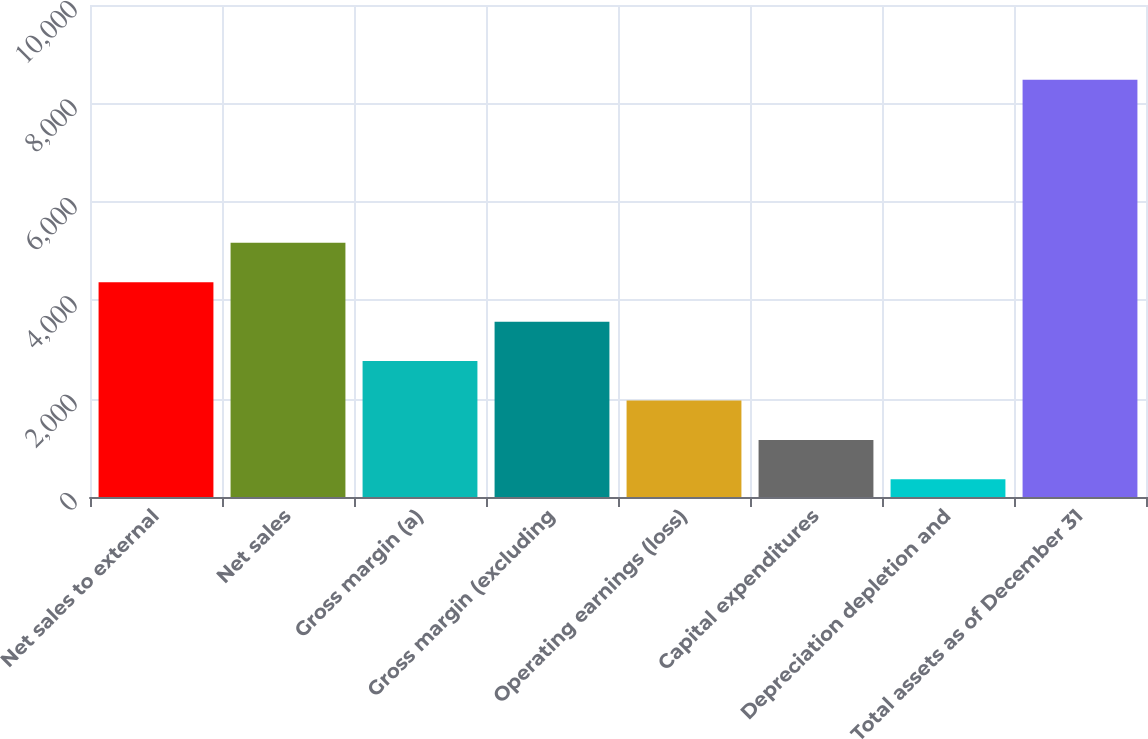<chart> <loc_0><loc_0><loc_500><loc_500><bar_chart><fcel>Net sales to external<fcel>Net sales<fcel>Gross margin (a)<fcel>Gross margin (excluding<fcel>Operating earnings (loss)<fcel>Capital expenditures<fcel>Depreciation depletion and<fcel>Total assets as of December 31<nl><fcel>4364.75<fcel>5165.76<fcel>2762.73<fcel>3563.74<fcel>1961.72<fcel>1160.71<fcel>359.7<fcel>8480.71<nl></chart> 